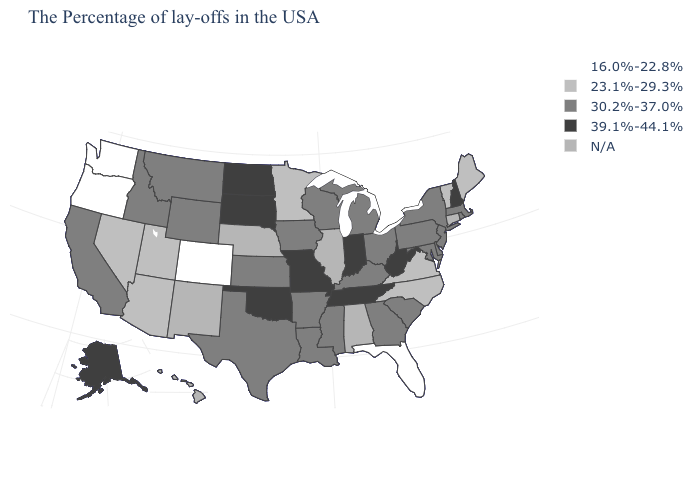Name the states that have a value in the range 16.0%-22.8%?
Give a very brief answer. Florida, Colorado, Washington, Oregon. Name the states that have a value in the range 16.0%-22.8%?
Keep it brief. Florida, Colorado, Washington, Oregon. Name the states that have a value in the range 23.1%-29.3%?
Keep it brief. Maine, Vermont, Virginia, North Carolina, Minnesota, Utah, Arizona, Nevada. Does the map have missing data?
Keep it brief. Yes. Name the states that have a value in the range 23.1%-29.3%?
Keep it brief. Maine, Vermont, Virginia, North Carolina, Minnesota, Utah, Arizona, Nevada. Is the legend a continuous bar?
Answer briefly. No. Among the states that border Maryland , which have the lowest value?
Keep it brief. Virginia. What is the value of Pennsylvania?
Write a very short answer. 30.2%-37.0%. Does the map have missing data?
Concise answer only. Yes. Name the states that have a value in the range 16.0%-22.8%?
Concise answer only. Florida, Colorado, Washington, Oregon. What is the highest value in the Northeast ?
Short answer required. 39.1%-44.1%. What is the value of Florida?
Give a very brief answer. 16.0%-22.8%. Is the legend a continuous bar?
Write a very short answer. No. What is the highest value in the USA?
Write a very short answer. 39.1%-44.1%. Name the states that have a value in the range N/A?
Write a very short answer. Connecticut, Alabama, Illinois, Nebraska, New Mexico, Hawaii. 